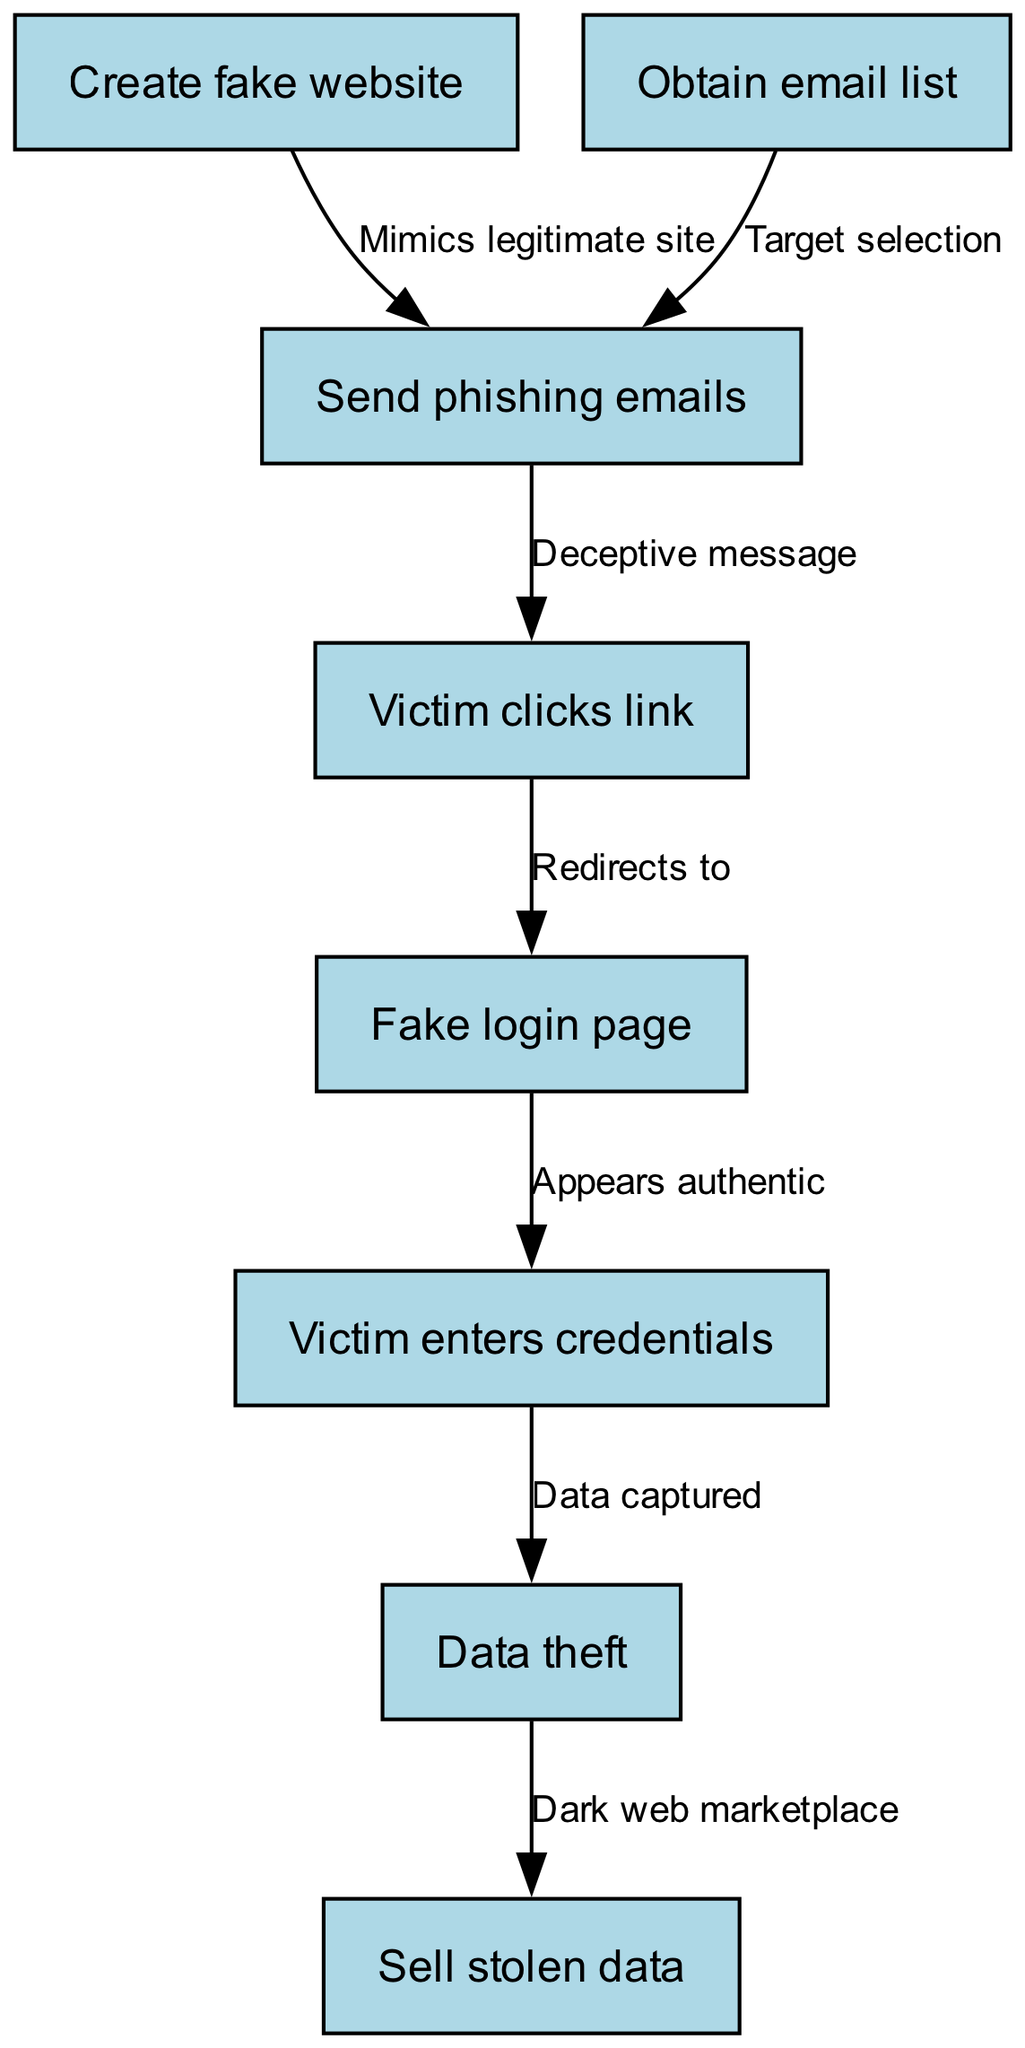What is the first step in the phishing scheme? The diagram shows the first node labeled "Create fake website," indicating that this is the initial step in the phishing scheme.
Answer: Create fake website How many nodes are there in the diagram? By counting the number of unique nodes in the provided data, there are a total of 8 nodes, each representing a specific step in the phishing scheme.
Answer: 8 What action follows after the victim clicks the link? According to the diagram, after the victim clicks the link (node 4), they are redirected to a fake login page (node 5).
Answer: Redirects to fake login page Which node indicates the completion of data theft? The last node in the flow, "Data theft," indicates that the process has reached a point where the data has been successfully captured from the victim.
Answer: Data theft What type of page appears authentic to the victim? The edge connecting nodes 5 and 6 mentions that the "Fake login page" appears authentic, implying that this node is designed to deceive the victim effectively.
Answer: Fake login page What does the scheme do with the stolen data? The diagram illustrates that once data theft is completed, the stolen data is then sold, as indicated by the connection between nodes 7 and 8.
Answer: Sell stolen data Which nodes are directly connected to the "Send phishing emails" step? The "Send phishing emails" step (node 3) is directly connected to the nodes for "Obtain email list" (node 2) for targeting and "Victim clicks link" (node 4) as the subsequent action.
Answer: Obtain email list, Victim clicks link After obtaining the email list, what is the next action depicted in the flowchart? The flowchart indicates that after obtaining the email list (node 2), the next action is to send phishing emails (node 3), clearly showing the progression of the scheme.
Answer: Send phishing emails 